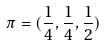Convert formula to latex. <formula><loc_0><loc_0><loc_500><loc_500>\pi = ( \frac { 1 } { 4 } , \frac { 1 } { 4 } , \frac { 1 } { 2 } )</formula> 